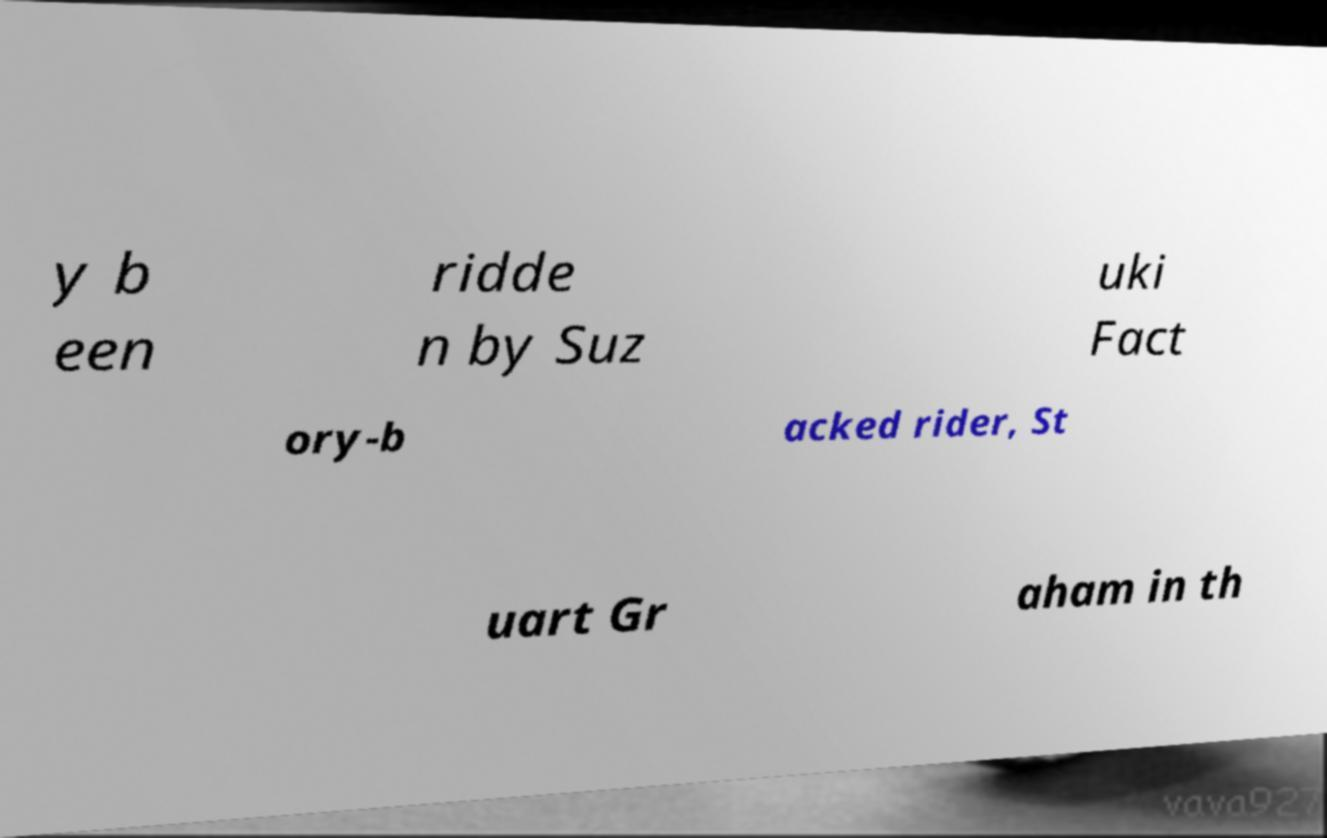Could you assist in decoding the text presented in this image and type it out clearly? y b een ridde n by Suz uki Fact ory-b acked rider, St uart Gr aham in th 